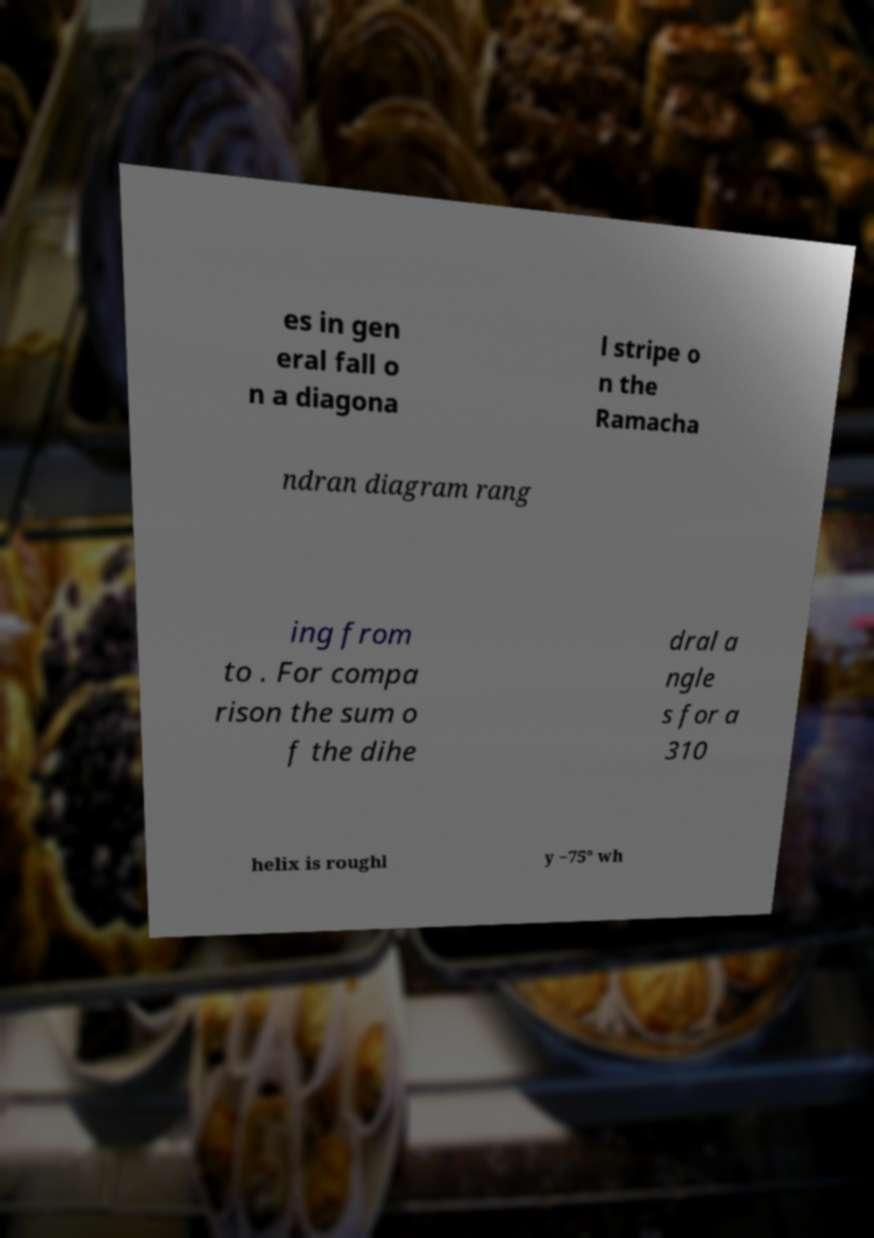Could you assist in decoding the text presented in this image and type it out clearly? es in gen eral fall o n a diagona l stripe o n the Ramacha ndran diagram rang ing from to . For compa rison the sum o f the dihe dral a ngle s for a 310 helix is roughl y −75° wh 